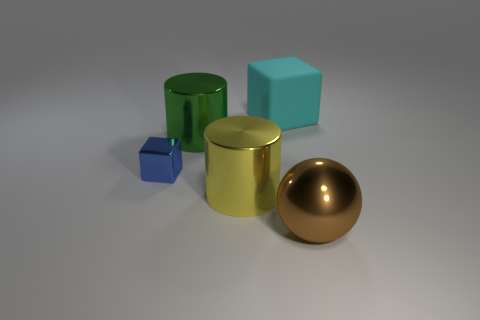Do the cyan matte object and the green cylinder have the same size?
Ensure brevity in your answer.  Yes. There is another object that is the same shape as the green thing; what is it made of?
Your response must be concise. Metal. Are there any other things that have the same material as the cyan thing?
Your response must be concise. No. How many green things are either shiny blocks or large metal things?
Make the answer very short. 1. What is the big cylinder that is in front of the blue thing made of?
Your answer should be compact. Metal. Is the number of yellow shiny things greater than the number of tiny gray shiny objects?
Provide a succinct answer. Yes. There is a large matte object that is behind the small blue cube; is its shape the same as the yellow object?
Offer a very short reply. No. How many shiny things are both to the left of the big metallic sphere and to the right of the small block?
Provide a succinct answer. 2. What number of other metallic objects have the same shape as the yellow thing?
Give a very brief answer. 1. There is a cube in front of the cube that is on the right side of the tiny blue cube; what color is it?
Make the answer very short. Blue. 